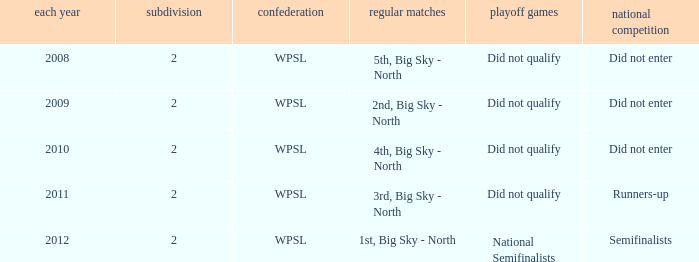What was the regular season name where they did not qualify for the playoffs in 2009? 2nd, Big Sky - North. 